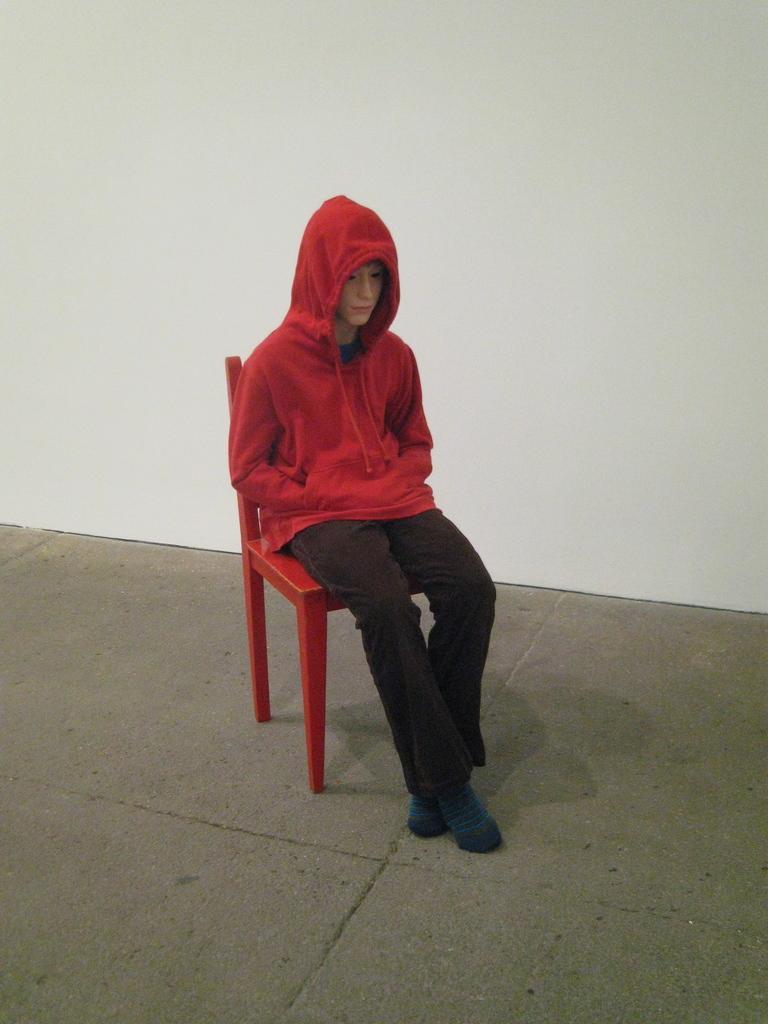Could you give a brief overview of what you see in this image? Here we can see a person sitting on the chair and the person is wearing clothes and socks. Here we can see the floor and the wall. 